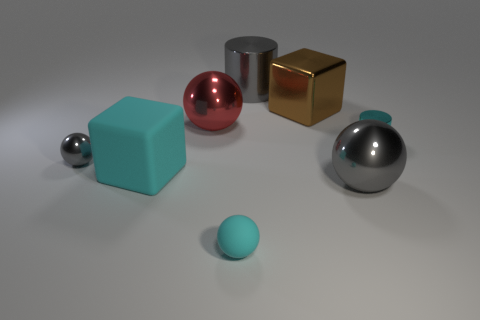Is there anything else of the same color as the metal block? Upon inspection of the image, while there are no other objects that match the exact color of the metal block, there are subtle reflections on the other metallic surfaces that faintly mimic its color due to their reflective properties. However, these are not inherent colors of the objects but merely reflections. 